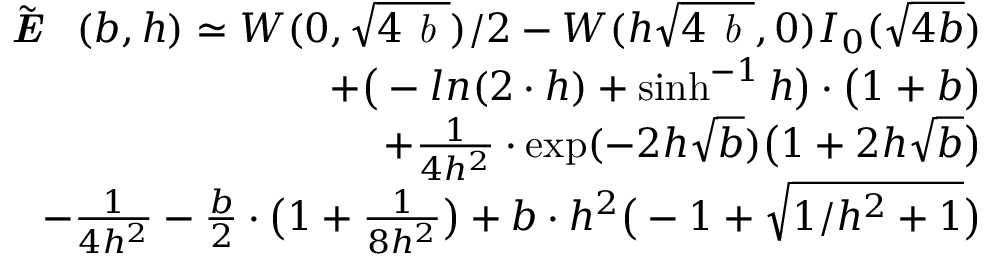<formula> <loc_0><loc_0><loc_500><loc_500>\begin{array} { r l r } & { \tilde { \emph { E } } ( b , h ) \simeq W ( 0 , \sqrt { 4 \emph { b } } ) / 2 - W ( h \sqrt { 4 \emph { b } } , 0 ) I _ { 0 } ( \sqrt { 4 b } ) } \\ & { + \left ( - \ln ( 2 \cdot h ) + \sinh ^ { - 1 } { h } \right ) \cdot \left ( 1 + b \right ) } \\ & { + { \frac { 1 } { 4 h ^ { 2 } } } \cdot \exp ( - 2 h \sqrt { b } ) \left ( 1 + 2 h \sqrt { b } \right ) } \\ & { - { \frac { 1 } { 4 h ^ { 2 } } } - { \frac { b } { 2 } } \cdot \left ( 1 + { \frac { 1 } { 8 h ^ { 2 } } } \right ) + b \cdot h ^ { 2 } \left ( - 1 + \sqrt { 1 / h ^ { 2 } + 1 } \right ) } \end{array}</formula> 